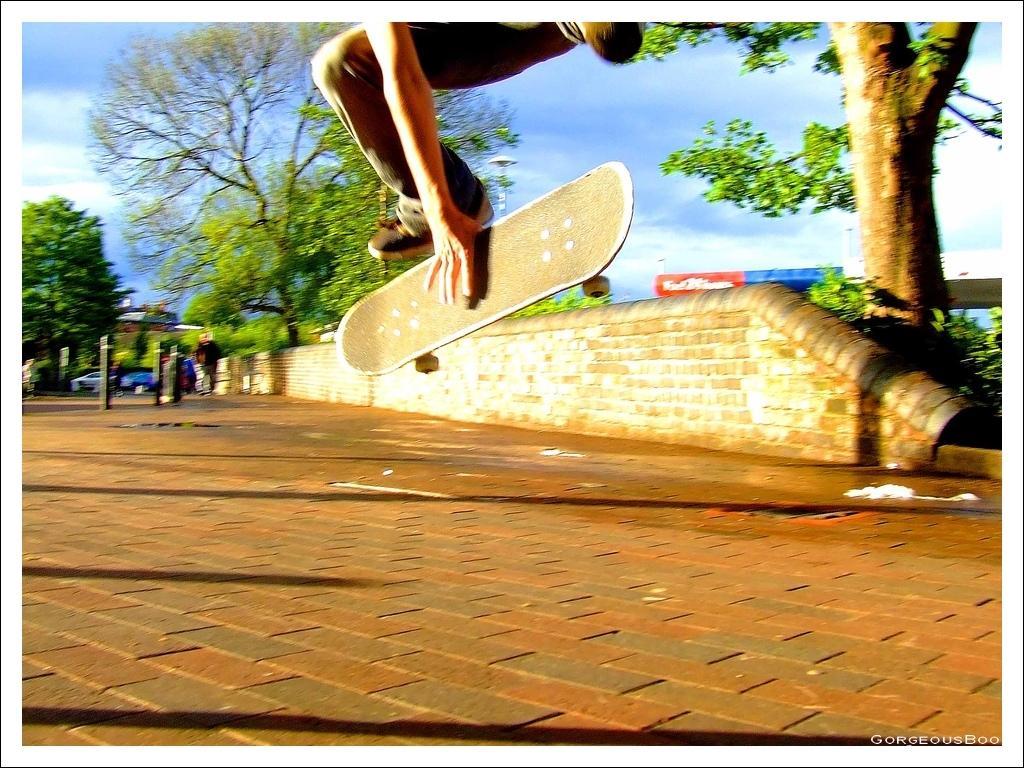In one or two sentences, can you explain what this image depicts? This is an edited picture. In this image there is a person jumping and holding the skateboard. At the back there are buildings, trees and there is a person and there is a vehicle. At the top there is sky and there are clouds. At the bottom there is a pavement. 